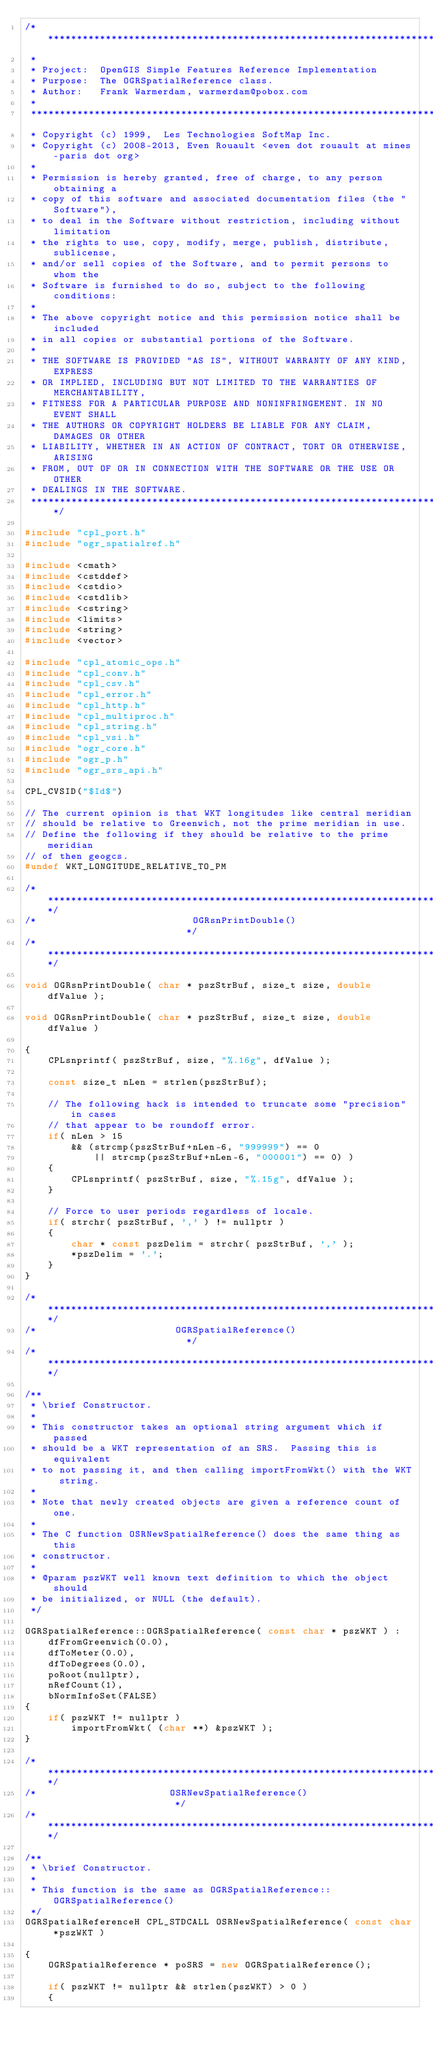Convert code to text. <code><loc_0><loc_0><loc_500><loc_500><_C++_>/******************************************************************************
 *
 * Project:  OpenGIS Simple Features Reference Implementation
 * Purpose:  The OGRSpatialReference class.
 * Author:   Frank Warmerdam, warmerdam@pobox.com
 *
 ******************************************************************************
 * Copyright (c) 1999,  Les Technologies SoftMap Inc.
 * Copyright (c) 2008-2013, Even Rouault <even dot rouault at mines-paris dot org>
 *
 * Permission is hereby granted, free of charge, to any person obtaining a
 * copy of this software and associated documentation files (the "Software"),
 * to deal in the Software without restriction, including without limitation
 * the rights to use, copy, modify, merge, publish, distribute, sublicense,
 * and/or sell copies of the Software, and to permit persons to whom the
 * Software is furnished to do so, subject to the following conditions:
 *
 * The above copyright notice and this permission notice shall be included
 * in all copies or substantial portions of the Software.
 *
 * THE SOFTWARE IS PROVIDED "AS IS", WITHOUT WARRANTY OF ANY KIND, EXPRESS
 * OR IMPLIED, INCLUDING BUT NOT LIMITED TO THE WARRANTIES OF MERCHANTABILITY,
 * FITNESS FOR A PARTICULAR PURPOSE AND NONINFRINGEMENT. IN NO EVENT SHALL
 * THE AUTHORS OR COPYRIGHT HOLDERS BE LIABLE FOR ANY CLAIM, DAMAGES OR OTHER
 * LIABILITY, WHETHER IN AN ACTION OF CONTRACT, TORT OR OTHERWISE, ARISING
 * FROM, OUT OF OR IN CONNECTION WITH THE SOFTWARE OR THE USE OR OTHER
 * DEALINGS IN THE SOFTWARE.
 ****************************************************************************/

#include "cpl_port.h"
#include "ogr_spatialref.h"

#include <cmath>
#include <cstddef>
#include <cstdio>
#include <cstdlib>
#include <cstring>
#include <limits>
#include <string>
#include <vector>

#include "cpl_atomic_ops.h"
#include "cpl_conv.h"
#include "cpl_csv.h"
#include "cpl_error.h"
#include "cpl_http.h"
#include "cpl_multiproc.h"
#include "cpl_string.h"
#include "cpl_vsi.h"
#include "ogr_core.h"
#include "ogr_p.h"
#include "ogr_srs_api.h"

CPL_CVSID("$Id$")

// The current opinion is that WKT longitudes like central meridian
// should be relative to Greenwich, not the prime meridian in use.
// Define the following if they should be relative to the prime meridian
// of then geogcs.
#undef WKT_LONGITUDE_RELATIVE_TO_PM

/************************************************************************/
/*                           OGRsnPrintDouble()                         */
/************************************************************************/

void OGRsnPrintDouble( char * pszStrBuf, size_t size, double dfValue );

void OGRsnPrintDouble( char * pszStrBuf, size_t size, double dfValue )

{
    CPLsnprintf( pszStrBuf, size, "%.16g", dfValue );

    const size_t nLen = strlen(pszStrBuf);

    // The following hack is intended to truncate some "precision" in cases
    // that appear to be roundoff error.
    if( nLen > 15
        && (strcmp(pszStrBuf+nLen-6, "999999") == 0
            || strcmp(pszStrBuf+nLen-6, "000001") == 0) )
    {
        CPLsnprintf( pszStrBuf, size, "%.15g", dfValue );
    }

    // Force to user periods regardless of locale.
    if( strchr( pszStrBuf, ',' ) != nullptr )
    {
        char * const pszDelim = strchr( pszStrBuf, ',' );
        *pszDelim = '.';
    }
}

/************************************************************************/
/*                        OGRSpatialReference()                         */
/************************************************************************/

/**
 * \brief Constructor.
 *
 * This constructor takes an optional string argument which if passed
 * should be a WKT representation of an SRS.  Passing this is equivalent
 * to not passing it, and then calling importFromWkt() with the WKT string.
 *
 * Note that newly created objects are given a reference count of one.
 *
 * The C function OSRNewSpatialReference() does the same thing as this
 * constructor.
 *
 * @param pszWKT well known text definition to which the object should
 * be initialized, or NULL (the default).
 */

OGRSpatialReference::OGRSpatialReference( const char * pszWKT ) :
    dfFromGreenwich(0.0),
    dfToMeter(0.0),
    dfToDegrees(0.0),
    poRoot(nullptr),
    nRefCount(1),
    bNormInfoSet(FALSE)
{
    if( pszWKT != nullptr )
        importFromWkt( (char **) &pszWKT );
}

/************************************************************************/
/*                       OSRNewSpatialReference()                       */
/************************************************************************/

/**
 * \brief Constructor.
 *
 * This function is the same as OGRSpatialReference::OGRSpatialReference()
 */
OGRSpatialReferenceH CPL_STDCALL OSRNewSpatialReference( const char *pszWKT )

{
    OGRSpatialReference * poSRS = new OGRSpatialReference();

    if( pszWKT != nullptr && strlen(pszWKT) > 0 )
    {</code> 